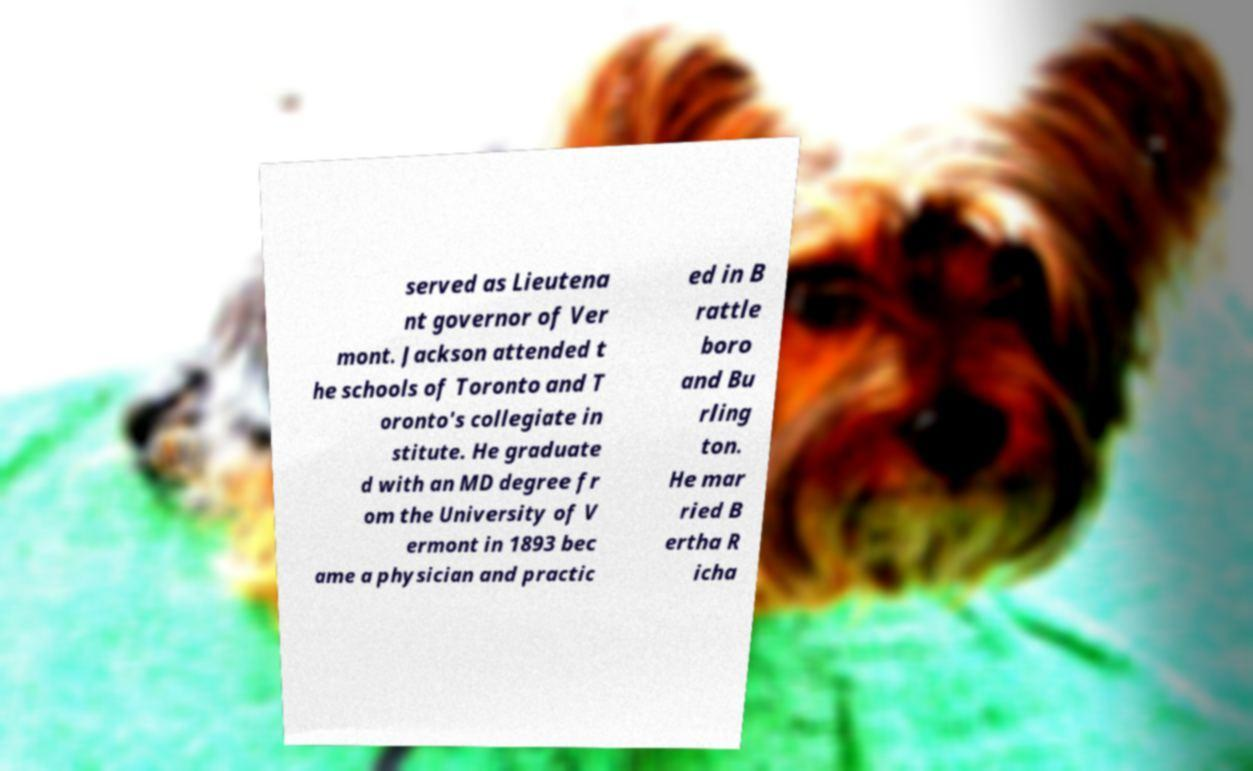Can you read and provide the text displayed in the image?This photo seems to have some interesting text. Can you extract and type it out for me? served as Lieutena nt governor of Ver mont. Jackson attended t he schools of Toronto and T oronto's collegiate in stitute. He graduate d with an MD degree fr om the University of V ermont in 1893 bec ame a physician and practic ed in B rattle boro and Bu rling ton. He mar ried B ertha R icha 